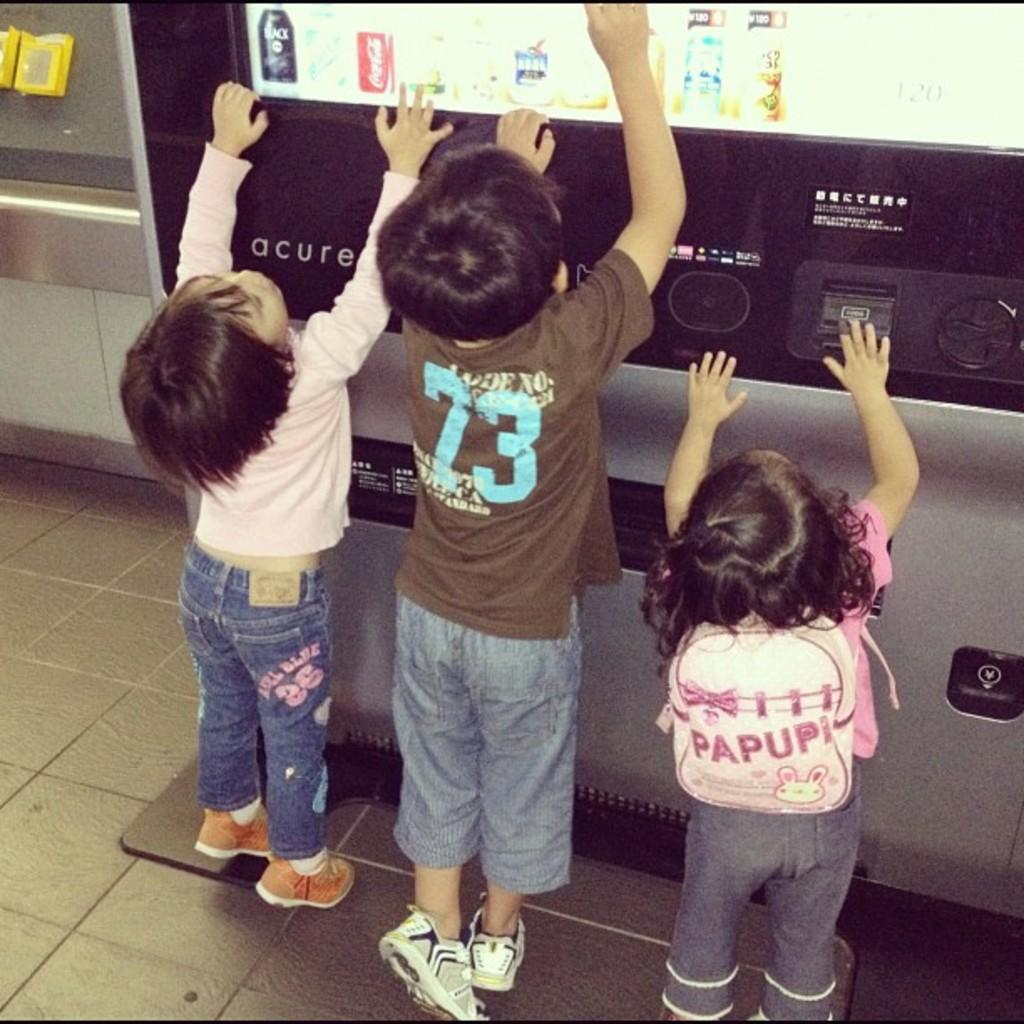How many children are in the image? There are three children in the image. Can you describe the gender of one of the children? One of the children is a girl. What is the girl wearing in the image? The girl is wearing a bag. What type of surface is visible in the image? There is a floor visible in the image. What can be found in the image for purchasing snacks and drinks? There is a vending machine for snacks and cool drinks in the image. What type of jam can be seen on the dinosaurs in the image? There are no dinosaurs or jam present in the image. How does the ice affect the children's activities in the image? There is no ice mentioned or visible in the image, so its effect on the children's activities cannot be determined. 